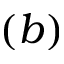Convert formula to latex. <formula><loc_0><loc_0><loc_500><loc_500>( b )</formula> 